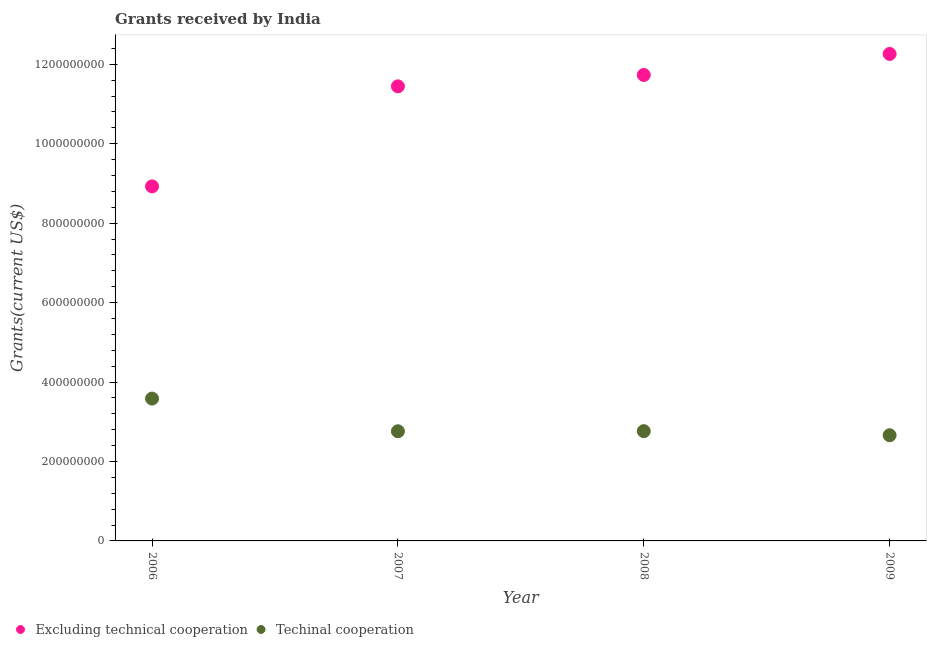How many different coloured dotlines are there?
Offer a terse response. 2. Is the number of dotlines equal to the number of legend labels?
Keep it short and to the point. Yes. What is the amount of grants received(including technical cooperation) in 2006?
Give a very brief answer. 3.58e+08. Across all years, what is the maximum amount of grants received(including technical cooperation)?
Offer a terse response. 3.58e+08. Across all years, what is the minimum amount of grants received(including technical cooperation)?
Give a very brief answer. 2.66e+08. In which year was the amount of grants received(including technical cooperation) maximum?
Make the answer very short. 2006. In which year was the amount of grants received(excluding technical cooperation) minimum?
Offer a terse response. 2006. What is the total amount of grants received(including technical cooperation) in the graph?
Keep it short and to the point. 1.18e+09. What is the difference between the amount of grants received(including technical cooperation) in 2006 and that in 2009?
Offer a terse response. 9.23e+07. What is the difference between the amount of grants received(including technical cooperation) in 2007 and the amount of grants received(excluding technical cooperation) in 2009?
Keep it short and to the point. -9.50e+08. What is the average amount of grants received(including technical cooperation) per year?
Your answer should be very brief. 2.94e+08. In the year 2009, what is the difference between the amount of grants received(excluding technical cooperation) and amount of grants received(including technical cooperation)?
Provide a succinct answer. 9.60e+08. In how many years, is the amount of grants received(excluding technical cooperation) greater than 520000000 US$?
Keep it short and to the point. 4. What is the ratio of the amount of grants received(including technical cooperation) in 2007 to that in 2009?
Keep it short and to the point. 1.04. Is the difference between the amount of grants received(including technical cooperation) in 2006 and 2007 greater than the difference between the amount of grants received(excluding technical cooperation) in 2006 and 2007?
Offer a very short reply. Yes. What is the difference between the highest and the second highest amount of grants received(including technical cooperation)?
Provide a succinct answer. 8.21e+07. What is the difference between the highest and the lowest amount of grants received(excluding technical cooperation)?
Provide a succinct answer. 3.33e+08. In how many years, is the amount of grants received(including technical cooperation) greater than the average amount of grants received(including technical cooperation) taken over all years?
Provide a short and direct response. 1. How many dotlines are there?
Give a very brief answer. 2. What is the difference between two consecutive major ticks on the Y-axis?
Your response must be concise. 2.00e+08. Does the graph contain any zero values?
Offer a terse response. No. Where does the legend appear in the graph?
Make the answer very short. Bottom left. How are the legend labels stacked?
Provide a succinct answer. Horizontal. What is the title of the graph?
Offer a terse response. Grants received by India. What is the label or title of the Y-axis?
Your answer should be very brief. Grants(current US$). What is the Grants(current US$) in Excluding technical cooperation in 2006?
Provide a succinct answer. 8.92e+08. What is the Grants(current US$) of Techinal cooperation in 2006?
Your answer should be very brief. 3.58e+08. What is the Grants(current US$) of Excluding technical cooperation in 2007?
Provide a succinct answer. 1.14e+09. What is the Grants(current US$) in Techinal cooperation in 2007?
Give a very brief answer. 2.76e+08. What is the Grants(current US$) of Excluding technical cooperation in 2008?
Provide a short and direct response. 1.17e+09. What is the Grants(current US$) in Techinal cooperation in 2008?
Give a very brief answer. 2.76e+08. What is the Grants(current US$) of Excluding technical cooperation in 2009?
Provide a succinct answer. 1.23e+09. What is the Grants(current US$) in Techinal cooperation in 2009?
Provide a short and direct response. 2.66e+08. Across all years, what is the maximum Grants(current US$) of Excluding technical cooperation?
Give a very brief answer. 1.23e+09. Across all years, what is the maximum Grants(current US$) in Techinal cooperation?
Give a very brief answer. 3.58e+08. Across all years, what is the minimum Grants(current US$) of Excluding technical cooperation?
Your response must be concise. 8.92e+08. Across all years, what is the minimum Grants(current US$) of Techinal cooperation?
Make the answer very short. 2.66e+08. What is the total Grants(current US$) of Excluding technical cooperation in the graph?
Ensure brevity in your answer.  4.44e+09. What is the total Grants(current US$) of Techinal cooperation in the graph?
Your response must be concise. 1.18e+09. What is the difference between the Grants(current US$) of Excluding technical cooperation in 2006 and that in 2007?
Offer a terse response. -2.52e+08. What is the difference between the Grants(current US$) of Techinal cooperation in 2006 and that in 2007?
Make the answer very short. 8.23e+07. What is the difference between the Grants(current US$) of Excluding technical cooperation in 2006 and that in 2008?
Ensure brevity in your answer.  -2.80e+08. What is the difference between the Grants(current US$) of Techinal cooperation in 2006 and that in 2008?
Ensure brevity in your answer.  8.21e+07. What is the difference between the Grants(current US$) of Excluding technical cooperation in 2006 and that in 2009?
Offer a terse response. -3.33e+08. What is the difference between the Grants(current US$) in Techinal cooperation in 2006 and that in 2009?
Offer a very short reply. 9.23e+07. What is the difference between the Grants(current US$) in Excluding technical cooperation in 2007 and that in 2008?
Offer a terse response. -2.87e+07. What is the difference between the Grants(current US$) in Excluding technical cooperation in 2007 and that in 2009?
Offer a very short reply. -8.16e+07. What is the difference between the Grants(current US$) in Techinal cooperation in 2007 and that in 2009?
Your response must be concise. 9.99e+06. What is the difference between the Grants(current US$) in Excluding technical cooperation in 2008 and that in 2009?
Offer a terse response. -5.29e+07. What is the difference between the Grants(current US$) of Techinal cooperation in 2008 and that in 2009?
Keep it short and to the point. 1.02e+07. What is the difference between the Grants(current US$) in Excluding technical cooperation in 2006 and the Grants(current US$) in Techinal cooperation in 2007?
Your response must be concise. 6.16e+08. What is the difference between the Grants(current US$) in Excluding technical cooperation in 2006 and the Grants(current US$) in Techinal cooperation in 2008?
Provide a short and direct response. 6.16e+08. What is the difference between the Grants(current US$) in Excluding technical cooperation in 2006 and the Grants(current US$) in Techinal cooperation in 2009?
Offer a very short reply. 6.26e+08. What is the difference between the Grants(current US$) of Excluding technical cooperation in 2007 and the Grants(current US$) of Techinal cooperation in 2008?
Your response must be concise. 8.68e+08. What is the difference between the Grants(current US$) in Excluding technical cooperation in 2007 and the Grants(current US$) in Techinal cooperation in 2009?
Your response must be concise. 8.78e+08. What is the difference between the Grants(current US$) of Excluding technical cooperation in 2008 and the Grants(current US$) of Techinal cooperation in 2009?
Your answer should be very brief. 9.07e+08. What is the average Grants(current US$) in Excluding technical cooperation per year?
Offer a terse response. 1.11e+09. What is the average Grants(current US$) in Techinal cooperation per year?
Offer a terse response. 2.94e+08. In the year 2006, what is the difference between the Grants(current US$) in Excluding technical cooperation and Grants(current US$) in Techinal cooperation?
Make the answer very short. 5.34e+08. In the year 2007, what is the difference between the Grants(current US$) of Excluding technical cooperation and Grants(current US$) of Techinal cooperation?
Provide a short and direct response. 8.68e+08. In the year 2008, what is the difference between the Grants(current US$) of Excluding technical cooperation and Grants(current US$) of Techinal cooperation?
Offer a very short reply. 8.97e+08. In the year 2009, what is the difference between the Grants(current US$) in Excluding technical cooperation and Grants(current US$) in Techinal cooperation?
Provide a succinct answer. 9.60e+08. What is the ratio of the Grants(current US$) in Excluding technical cooperation in 2006 to that in 2007?
Keep it short and to the point. 0.78. What is the ratio of the Grants(current US$) in Techinal cooperation in 2006 to that in 2007?
Your answer should be compact. 1.3. What is the ratio of the Grants(current US$) of Excluding technical cooperation in 2006 to that in 2008?
Your answer should be very brief. 0.76. What is the ratio of the Grants(current US$) of Techinal cooperation in 2006 to that in 2008?
Give a very brief answer. 1.3. What is the ratio of the Grants(current US$) of Excluding technical cooperation in 2006 to that in 2009?
Ensure brevity in your answer.  0.73. What is the ratio of the Grants(current US$) of Techinal cooperation in 2006 to that in 2009?
Offer a terse response. 1.35. What is the ratio of the Grants(current US$) in Excluding technical cooperation in 2007 to that in 2008?
Ensure brevity in your answer.  0.98. What is the ratio of the Grants(current US$) in Techinal cooperation in 2007 to that in 2008?
Offer a very short reply. 1. What is the ratio of the Grants(current US$) of Excluding technical cooperation in 2007 to that in 2009?
Offer a terse response. 0.93. What is the ratio of the Grants(current US$) of Techinal cooperation in 2007 to that in 2009?
Offer a terse response. 1.04. What is the ratio of the Grants(current US$) of Excluding technical cooperation in 2008 to that in 2009?
Your response must be concise. 0.96. What is the ratio of the Grants(current US$) in Techinal cooperation in 2008 to that in 2009?
Your answer should be very brief. 1.04. What is the difference between the highest and the second highest Grants(current US$) of Excluding technical cooperation?
Provide a short and direct response. 5.29e+07. What is the difference between the highest and the second highest Grants(current US$) of Techinal cooperation?
Your response must be concise. 8.21e+07. What is the difference between the highest and the lowest Grants(current US$) of Excluding technical cooperation?
Give a very brief answer. 3.33e+08. What is the difference between the highest and the lowest Grants(current US$) of Techinal cooperation?
Your answer should be very brief. 9.23e+07. 